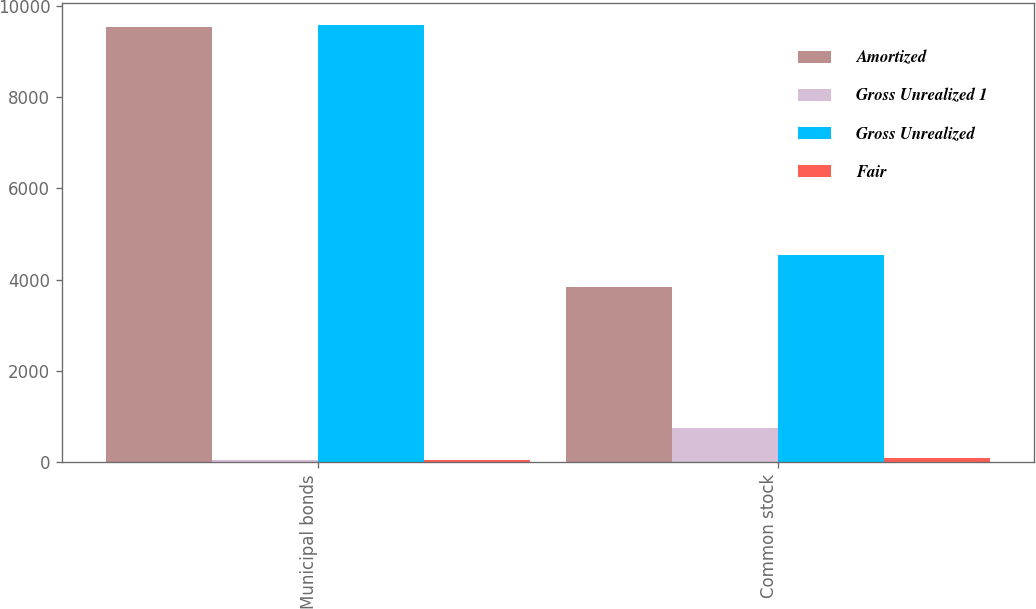<chart> <loc_0><loc_0><loc_500><loc_500><stacked_bar_chart><ecel><fcel>Municipal bonds<fcel>Common stock<nl><fcel>Amortized<fcel>9527<fcel>3845<nl><fcel>Gross Unrealized 1<fcel>47<fcel>747<nl><fcel>Gross Unrealized<fcel>9568<fcel>4547<nl><fcel>Fair<fcel>53<fcel>100<nl></chart> 